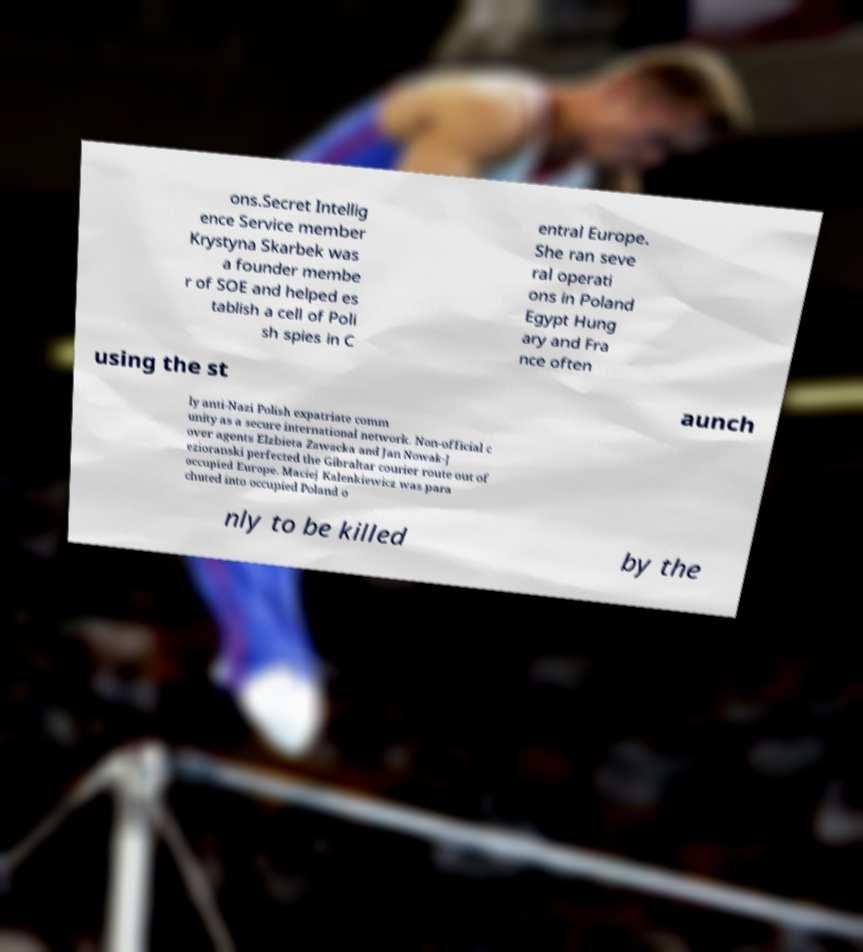Please read and relay the text visible in this image. What does it say? ons.Secret Intellig ence Service member Krystyna Skarbek was a founder membe r of SOE and helped es tablish a cell of Poli sh spies in C entral Europe. She ran seve ral operati ons in Poland Egypt Hung ary and Fra nce often using the st aunch ly anti-Nazi Polish expatriate comm unity as a secure international network. Non-official c over agents Elzbieta Zawacka and Jan Nowak-J ezioranski perfected the Gibraltar courier route out of occupied Europe. Maciej Kalenkiewicz was para chuted into occupied Poland o nly to be killed by the 